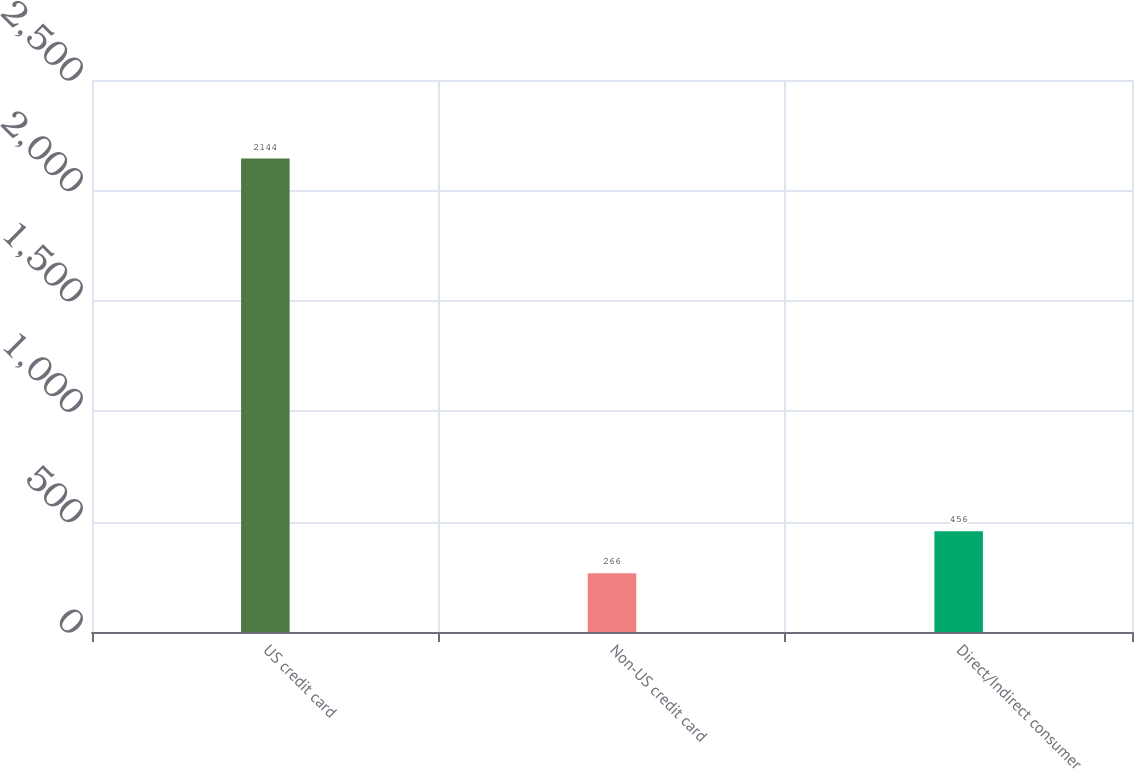Convert chart. <chart><loc_0><loc_0><loc_500><loc_500><bar_chart><fcel>US credit card<fcel>Non-US credit card<fcel>Direct/Indirect consumer<nl><fcel>2144<fcel>266<fcel>456<nl></chart> 